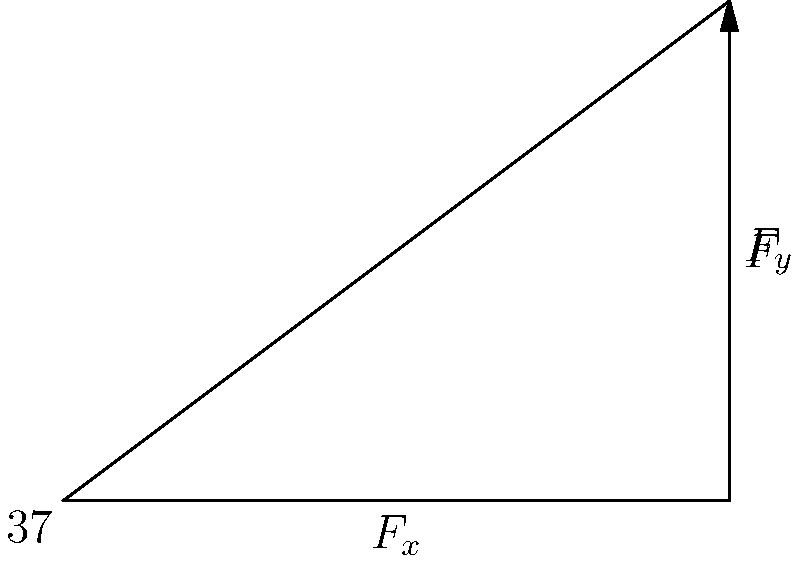As you're helping your younger sibling with their physics homework, you come across a problem about resolving forces. A force $F$ of magnitude 50 N acts at an angle of 37° to the horizontal. What is the vertical component of this force? Let's approach this step-by-step, as if we're explaining it to someone new to the concept:

1) First, we need to understand that any force can be broken down into horizontal (x) and vertical (y) components.

2) The right triangle in the diagram represents this breakdown. The hypotenuse is the original force $F$, while the other two sides represent its components.

3) We're asked to find the vertical component, which is $F_y$ in the diagram.

4) In a right triangle, the relationship between the hypotenuse (our force $F$) and the opposite side (our vertical component $F_y$) is given by the sine function:

   $\sin \theta = \frac{\text{opposite}}{\text{hypotenuse}} = \frac{F_y}{F}$

5) We know the angle $\theta$ is 37° and the magnitude of $F$ is 50 N. Let's plug these into our equation:

   $\sin 37° = \frac{F_y}{50}$

6) To solve for $F_y$, we multiply both sides by 50:

   $F_y = 50 \sin 37°$

7) Using a calculator (or remembering that $\sin 37° \approx 0.6018$):

   $F_y = 50 * 0.6018 = 30.09$ N

8) Rounding to two decimal places, we get 30.09 N.
Answer: 30.09 N 